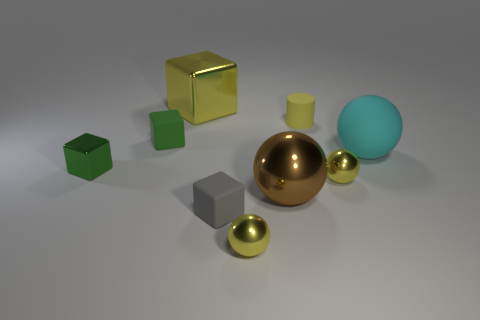How would you describe the lighting in this scene? The lighting in the scene has a soft quality with diffuse shadows, suggesting an overcast ambiance or a studio environment with softbox lighting equipment to create a gentle illumination allowing for subtle texture details to be visible. 